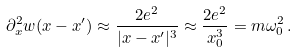<formula> <loc_0><loc_0><loc_500><loc_500>\partial _ { x } ^ { 2 } w ( x - x ^ { \prime } ) \approx \frac { 2 e ^ { 2 } } { | x - x ^ { \prime } | ^ { 3 } } \approx \frac { 2 e ^ { 2 } } { x _ { 0 } ^ { 3 } } = m \omega _ { 0 } ^ { 2 } \, .</formula> 